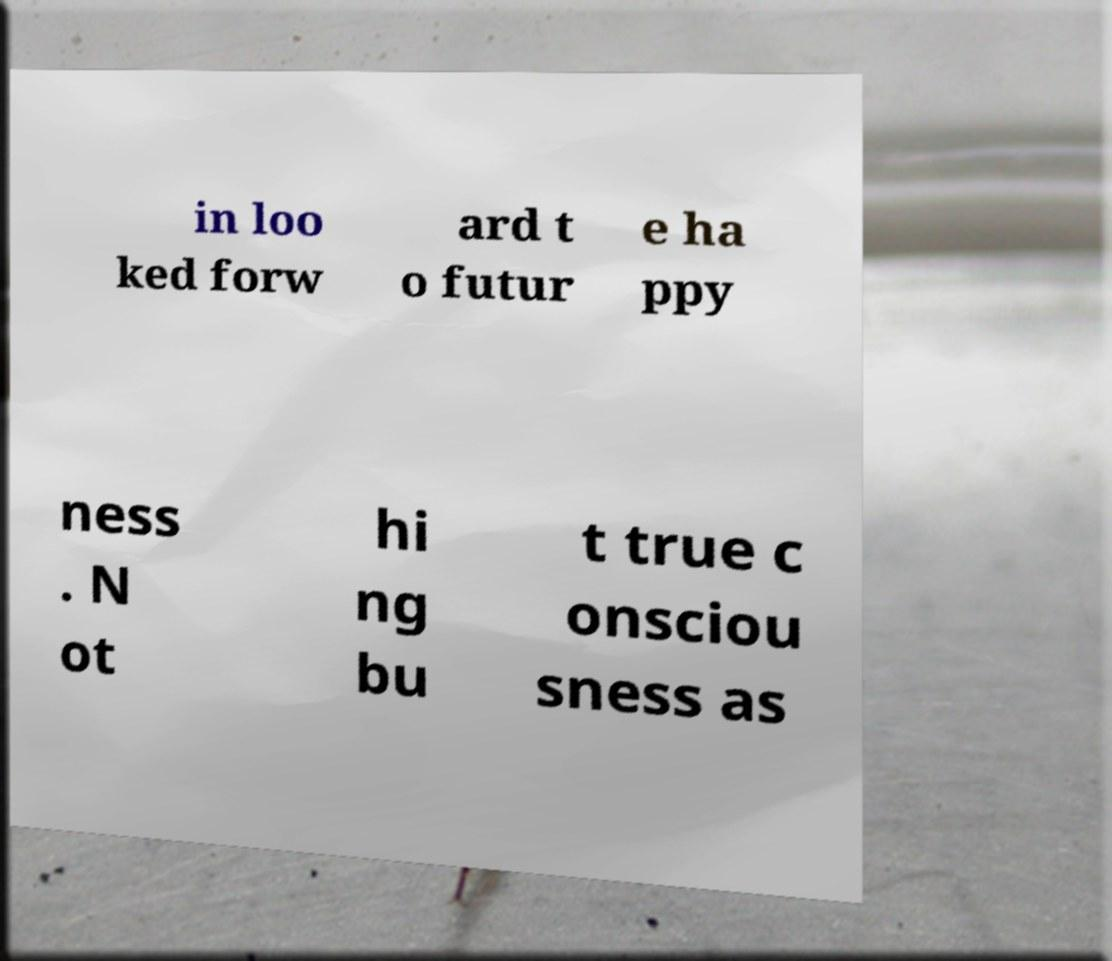What messages or text are displayed in this image? I need them in a readable, typed format. in loo ked forw ard t o futur e ha ppy ness . N ot hi ng bu t true c onsciou sness as 